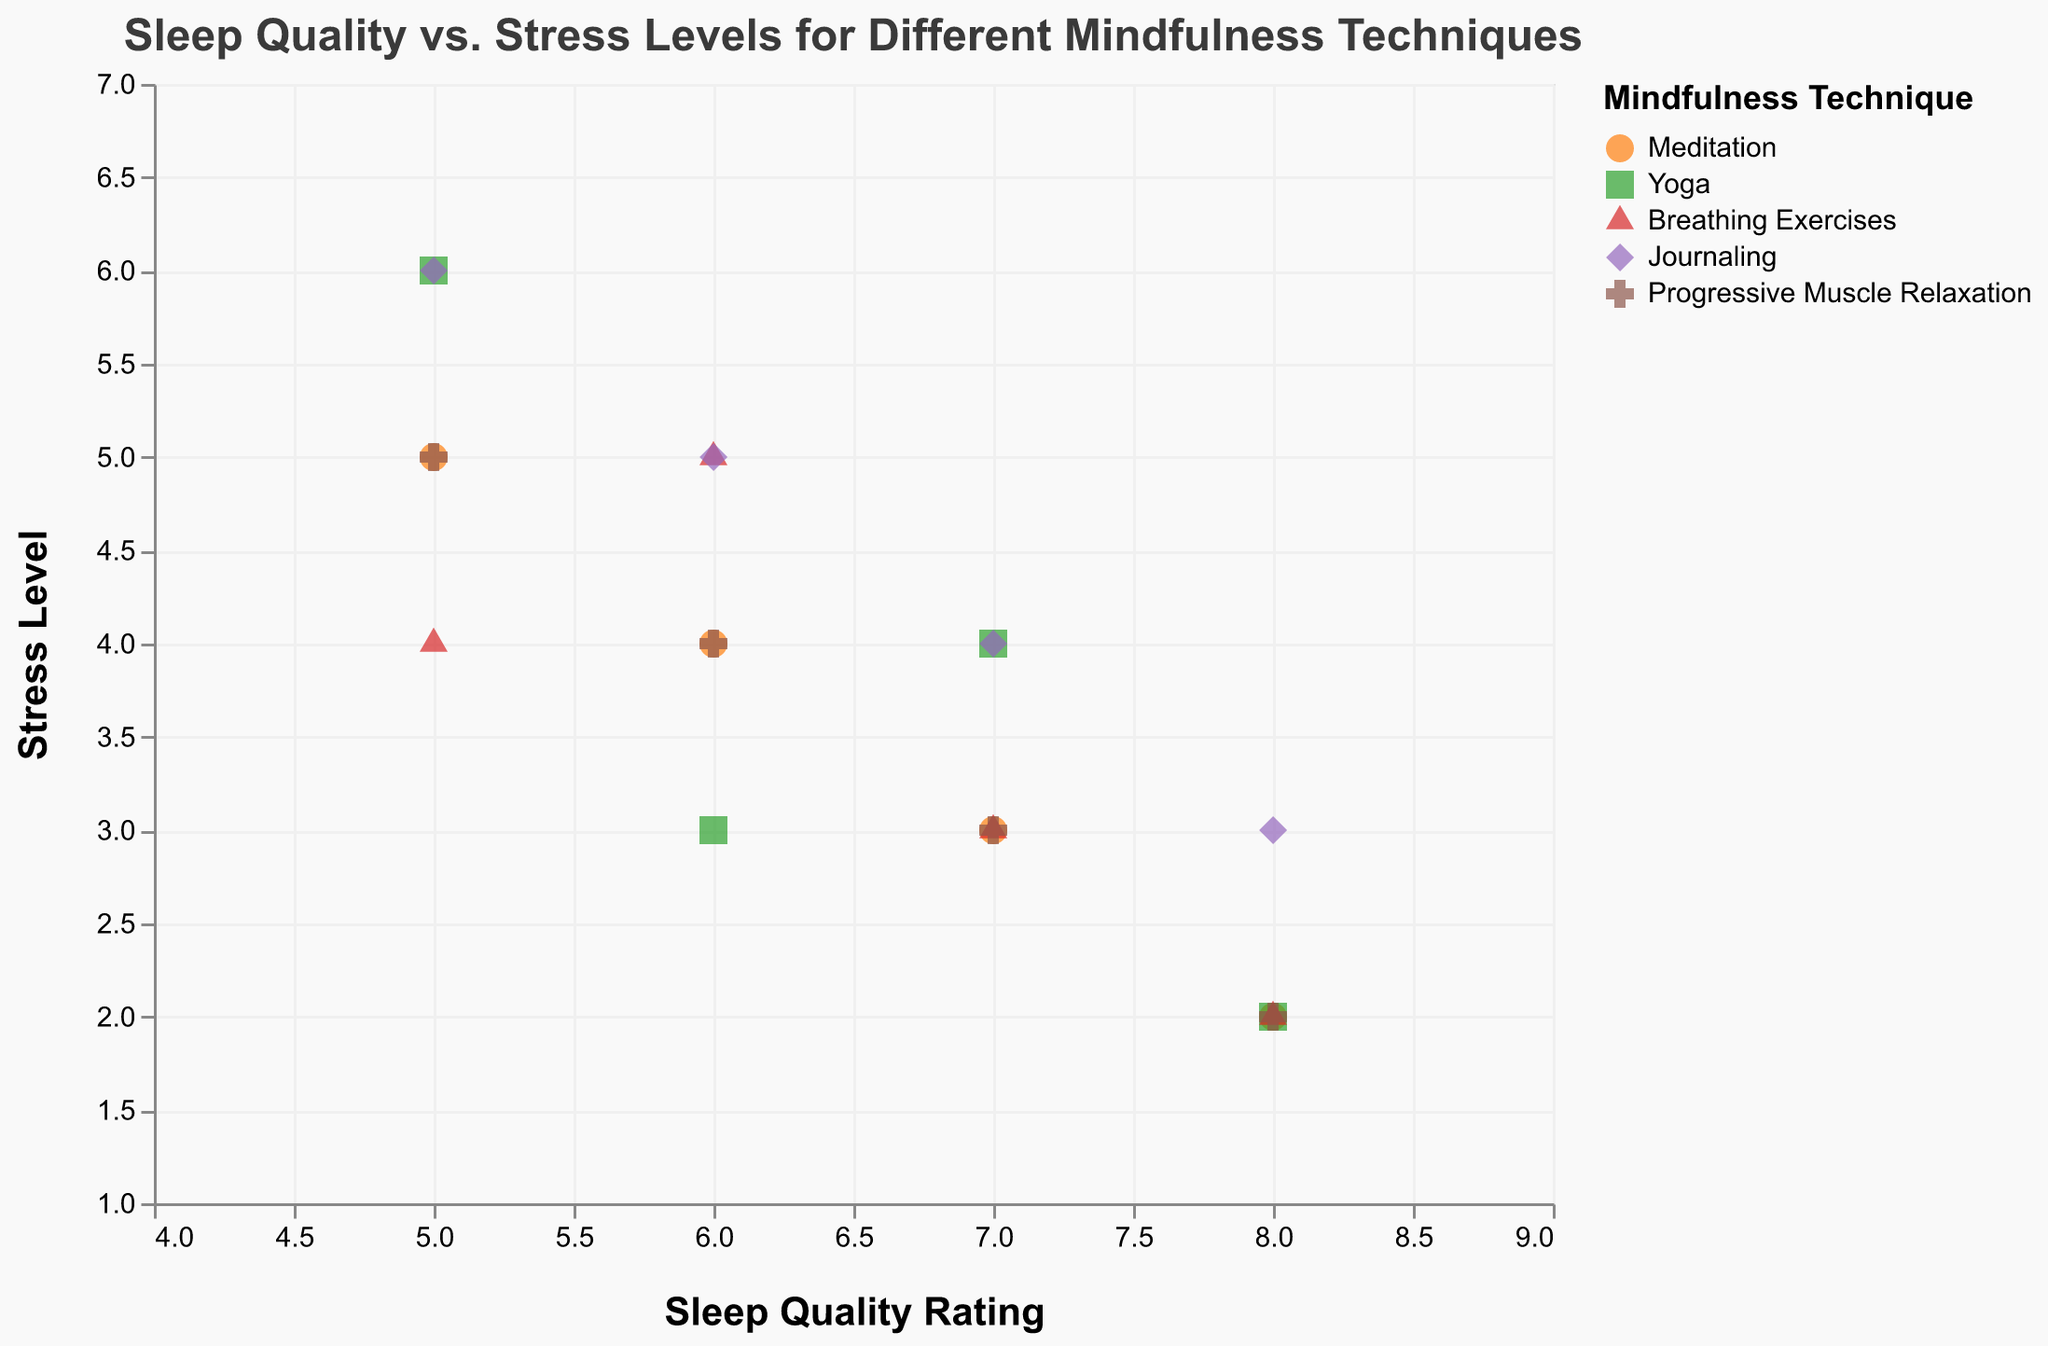What is the title of the plot? The title of the plot is displayed at the top of the figure. It reads: "Sleep Quality vs. Stress Levels for Different Mindfulness Techniques."
Answer: Sleep Quality vs. Stress Levels for Different Mindfulness Techniques How many mindfulness techniques are represented in the plot? By observing the legend of the plot, we can count the different mindfulness techniques listed: Meditation, Yoga, Breathing Exercises, Journaling, and Progressive Muscle Relaxation.
Answer: 5 Which mindfulness technique has data points shaped as triangles? By referring to the legend, we see that triangles represent "Breathing Exercises."
Answer: Breathing Exercises For which mindfulness technique is the highest sleep quality rating reported? Look for the highest value on the x-axis labeled "Sleep Quality Rating" and check the corresponding color/shape in the plot. The highest rating (8) is observed in several techniques, including Meditation, Yoga, Breathing Exercises, Journaling, and Progressive Muscle Relaxation.
Answer: Multiple techniques (Meditation, Yoga, Breathing Exercises, Journaling, Progressive Muscle Relaxation) Which client has the highest stress level, and what mindfulness technique are they practicing? Leverage the y-axis labeled "Stress Level" and find the highest value (6). Identify the corresponding data points. Clients practicing Yoga and Journaling (Client8 and Client16) have a stress level of 6.
Answer: Client8 (Yoga) and Client16 (Journaling) Which mindfulness technique shows the lowest stress levels across its clients? Find the technique with data points closest to the lowest value on the y-axis (1) and verify the stress levels. "Stress Level" 2 is the lowest, seen in Meditation, Yoga, Breathing Exercises, Journaling, and Progressive Muscle Relaxation.
Answer: Multiple techniques (Meditation, Yoga, Breathing Exercises, Journaling, Progressive Muscle Relaxation) What is the average sleep quality rating for clients practicing Yoga? Look at all data points for "Yoga" (green squares) and sum the Sleep Quality Ratings: 7, 6, 8, 5. Calculate the average: (7+6+8+5)/4 = 26/4 = 6.5.
Answer: 6.5 Which mindfulness technique has the most balanced range of stress levels? By observing the spread of data points along the y-axis labeled "Stress Level," check each technique's range from minimum to maximum stress levels. Techniques like Meditation, Progressive Muscle Relaxation have data points from 2 to 5, 2 to 5, respectively.
Answer: Meditation, Progressive Muscle Relaxation What is the correlation between sleep quality rating and stress levels for the Breathing Exercises technique? Identify the pattern in the data points labeled "Breathing Exercises" (red triangles), and check the trend. Higher sleep quality ratings seem to correspond to lower stress levels.
Answer: Negative correlation 